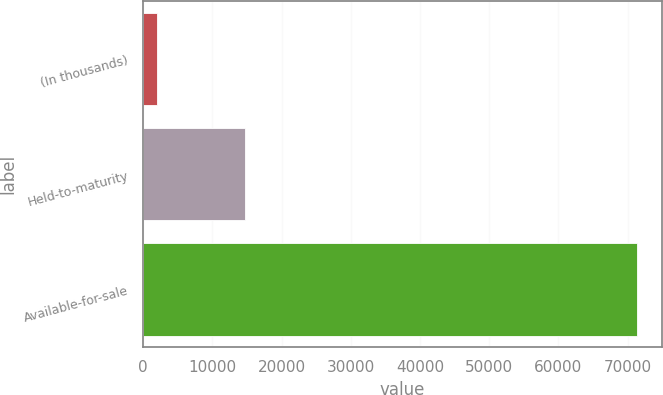<chart> <loc_0><loc_0><loc_500><loc_500><bar_chart><fcel>(In thousands)<fcel>Held-to-maturity<fcel>Available-for-sale<nl><fcel>2014<fcel>14770<fcel>71365<nl></chart> 